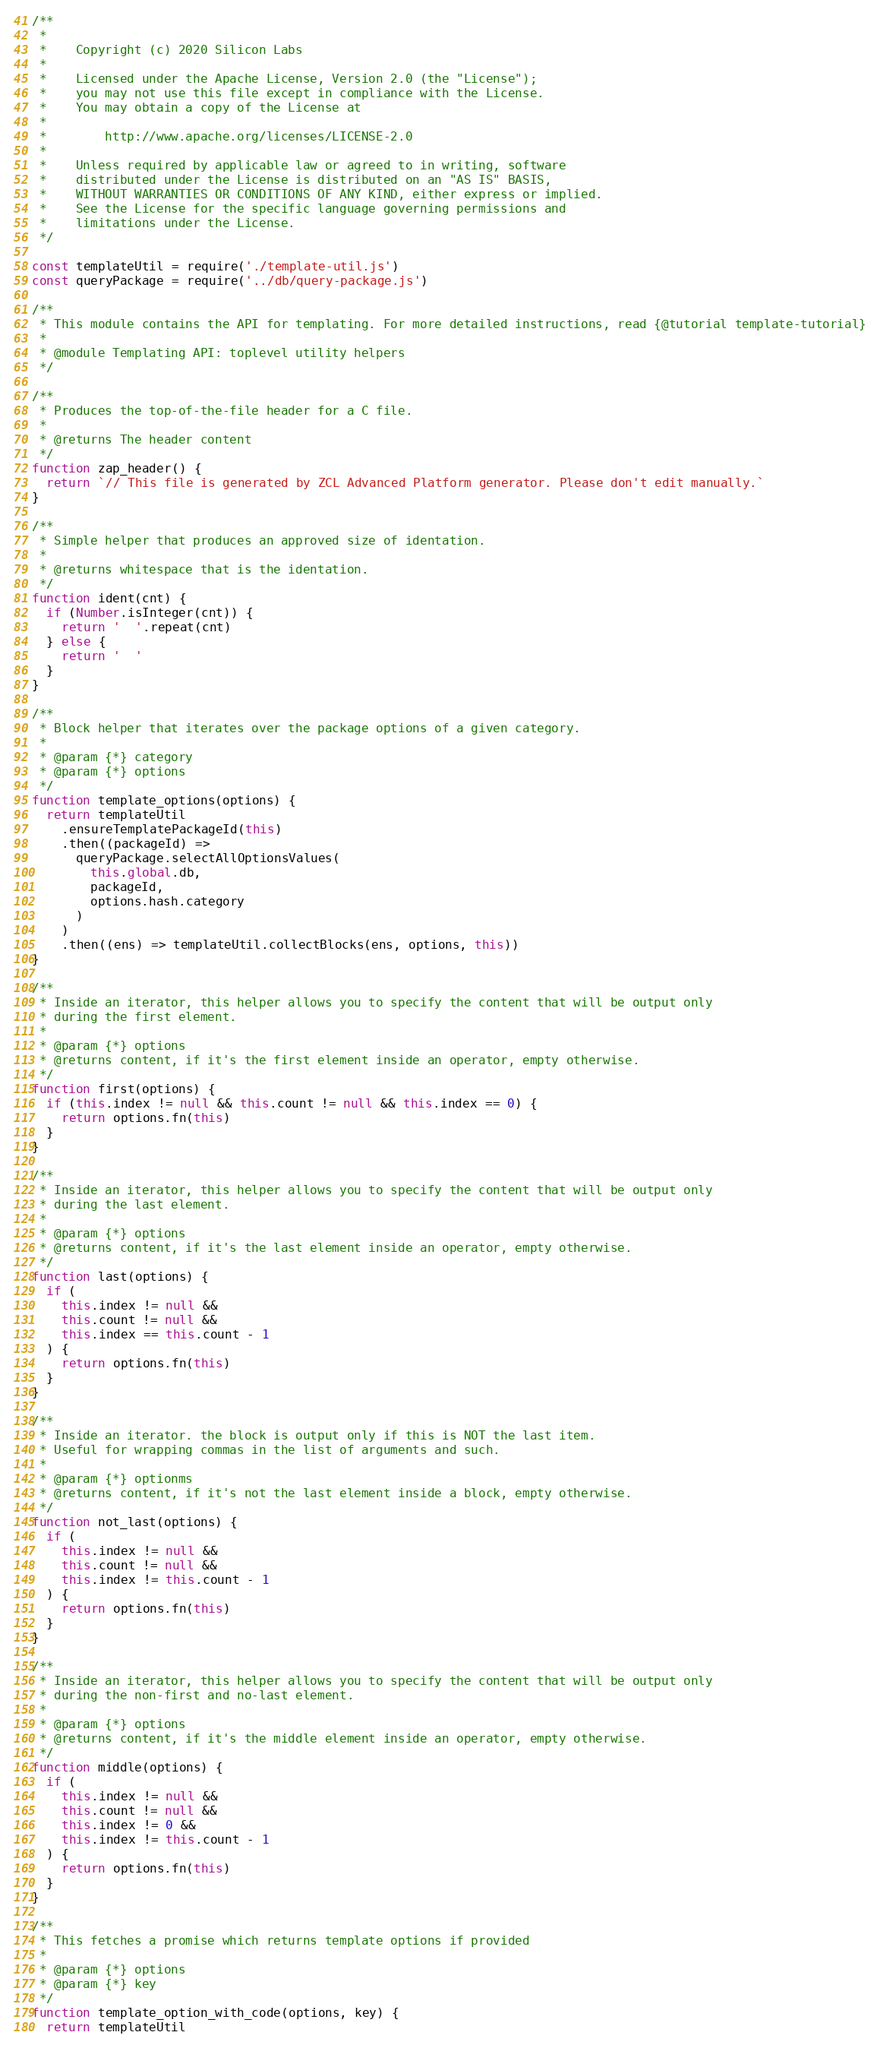Convert code to text. <code><loc_0><loc_0><loc_500><loc_500><_JavaScript_>/**
 *
 *    Copyright (c) 2020 Silicon Labs
 *
 *    Licensed under the Apache License, Version 2.0 (the "License");
 *    you may not use this file except in compliance with the License.
 *    You may obtain a copy of the License at
 *
 *        http://www.apache.org/licenses/LICENSE-2.0
 *
 *    Unless required by applicable law or agreed to in writing, software
 *    distributed under the License is distributed on an "AS IS" BASIS,
 *    WITHOUT WARRANTIES OR CONDITIONS OF ANY KIND, either express or implied.
 *    See the License for the specific language governing permissions and
 *    limitations under the License.
 */

const templateUtil = require('./template-util.js')
const queryPackage = require('../db/query-package.js')

/**
 * This module contains the API for templating. For more detailed instructions, read {@tutorial template-tutorial}
 *
 * @module Templating API: toplevel utility helpers
 */

/**
 * Produces the top-of-the-file header for a C file.
 *
 * @returns The header content
 */
function zap_header() {
  return `// This file is generated by ZCL Advanced Platform generator. Please don't edit manually.`
}

/**
 * Simple helper that produces an approved size of identation.
 *
 * @returns whitespace that is the identation.
 */
function ident(cnt) {
  if (Number.isInteger(cnt)) {
    return '  '.repeat(cnt)
  } else {
    return '  '
  }
}

/**
 * Block helper that iterates over the package options of a given category.
 *
 * @param {*} category
 * @param {*} options
 */
function template_options(options) {
  return templateUtil
    .ensureTemplatePackageId(this)
    .then((packageId) =>
      queryPackage.selectAllOptionsValues(
        this.global.db,
        packageId,
        options.hash.category
      )
    )
    .then((ens) => templateUtil.collectBlocks(ens, options, this))
}

/**
 * Inside an iterator, this helper allows you to specify the content that will be output only
 * during the first element.
 *
 * @param {*} options
 * @returns content, if it's the first element inside an operator, empty otherwise.
 */
function first(options) {
  if (this.index != null && this.count != null && this.index == 0) {
    return options.fn(this)
  }
}

/**
 * Inside an iterator, this helper allows you to specify the content that will be output only
 * during the last element.
 *
 * @param {*} options
 * @returns content, if it's the last element inside an operator, empty otherwise.
 */
function last(options) {
  if (
    this.index != null &&
    this.count != null &&
    this.index == this.count - 1
  ) {
    return options.fn(this)
  }
}

/**
 * Inside an iterator. the block is output only if this is NOT the last item.
 * Useful for wrapping commas in the list of arguments and such.
 *
 * @param {*} optionms
 * @returns content, if it's not the last element inside a block, empty otherwise.
 */
function not_last(options) {
  if (
    this.index != null &&
    this.count != null &&
    this.index != this.count - 1
  ) {
    return options.fn(this)
  }
}

/**
 * Inside an iterator, this helper allows you to specify the content that will be output only
 * during the non-first and no-last element.
 *
 * @param {*} options
 * @returns content, if it's the middle element inside an operator, empty otherwise.
 */
function middle(options) {
  if (
    this.index != null &&
    this.count != null &&
    this.index != 0 &&
    this.index != this.count - 1
  ) {
    return options.fn(this)
  }
}

/**
 * This fetches a promise which returns template options if provided
 *
 * @param {*} options
 * @param {*} key
 */
function template_option_with_code(options, key) {
  return templateUtil</code> 